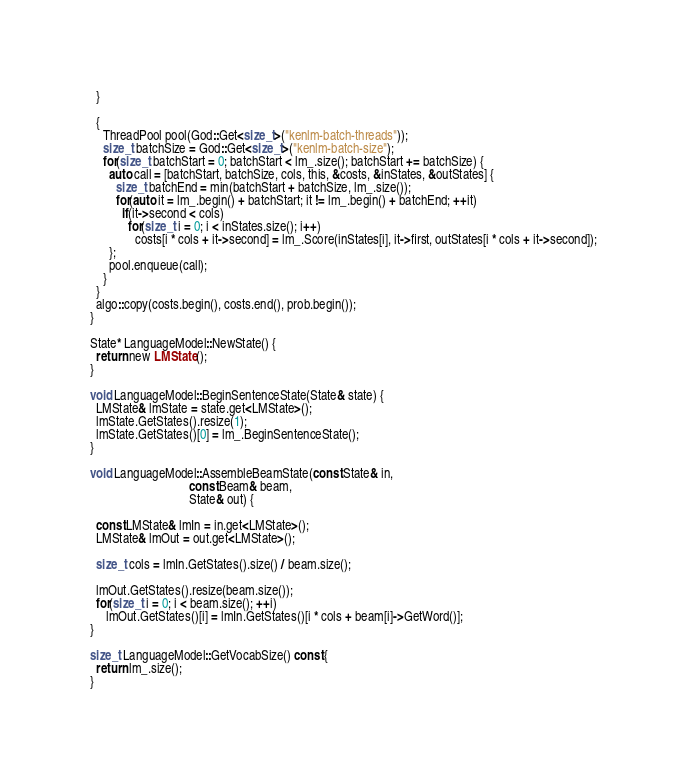Convert code to text. <code><loc_0><loc_0><loc_500><loc_500><_Cuda_>  }

  {
	ThreadPool pool(God::Get<size_t>("kenlm-batch-threads"));
	size_t batchSize = God::Get<size_t>("kenlm-batch-size");
	for(size_t batchStart = 0; batchStart < lm_.size(); batchStart += batchSize) {
	  auto call = [batchStart, batchSize, cols, this, &costs, &inStates, &outStates] {
		size_t batchEnd = min(batchStart + batchSize, lm_.size());
		for(auto it = lm_.begin() + batchStart; it != lm_.begin() + batchEnd; ++it)
		  if(it->second < cols)
			for(size_t i = 0; i < inStates.size(); i++)
			  costs[i * cols + it->second] = lm_.Score(inStates[i], it->first, outStates[i * cols + it->second]);
	  };
	  pool.enqueue(call);
	}
  }
  algo::copy(costs.begin(), costs.end(), prob.begin());
}

State* LanguageModel::NewState() {
  return new LMState();
}

void LanguageModel::BeginSentenceState(State& state) {
  LMState& lmState = state.get<LMState>();
  lmState.GetStates().resize(1);
  lmState.GetStates()[0] = lm_.BeginSentenceState();
}

void LanguageModel::AssembleBeamState(const State& in,
							   const Beam& beam,
							   State& out) {

  const LMState& lmIn = in.get<LMState>();
  LMState& lmOut = out.get<LMState>();

  size_t cols = lmIn.GetStates().size() / beam.size();

  lmOut.GetStates().resize(beam.size());
  for(size_t i = 0; i < beam.size(); ++i)
	 lmOut.GetStates()[i] = lmIn.GetStates()[i * cols + beam[i]->GetWord()];
}

size_t LanguageModel::GetVocabSize() const {
  return lm_.size();
}

</code> 